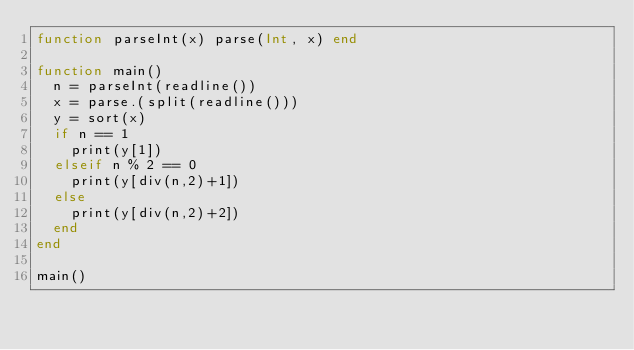Convert code to text. <code><loc_0><loc_0><loc_500><loc_500><_Julia_>function parseInt(x) parse(Int, x) end

function main()
  n = parseInt(readline())
  x = parse.(split(readline()))
  y = sort(x)
  if n == 1
    print(y[1])
  elseif n % 2 == 0
    print(y[div(n,2)+1])
  else
    print(y[div(n,2)+2])
  end
end

main()
</code> 